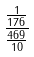Convert formula to latex. <formula><loc_0><loc_0><loc_500><loc_500>\frac { \frac { 1 } { 1 7 6 } } { \frac { 4 6 9 } { 1 0 } }</formula> 